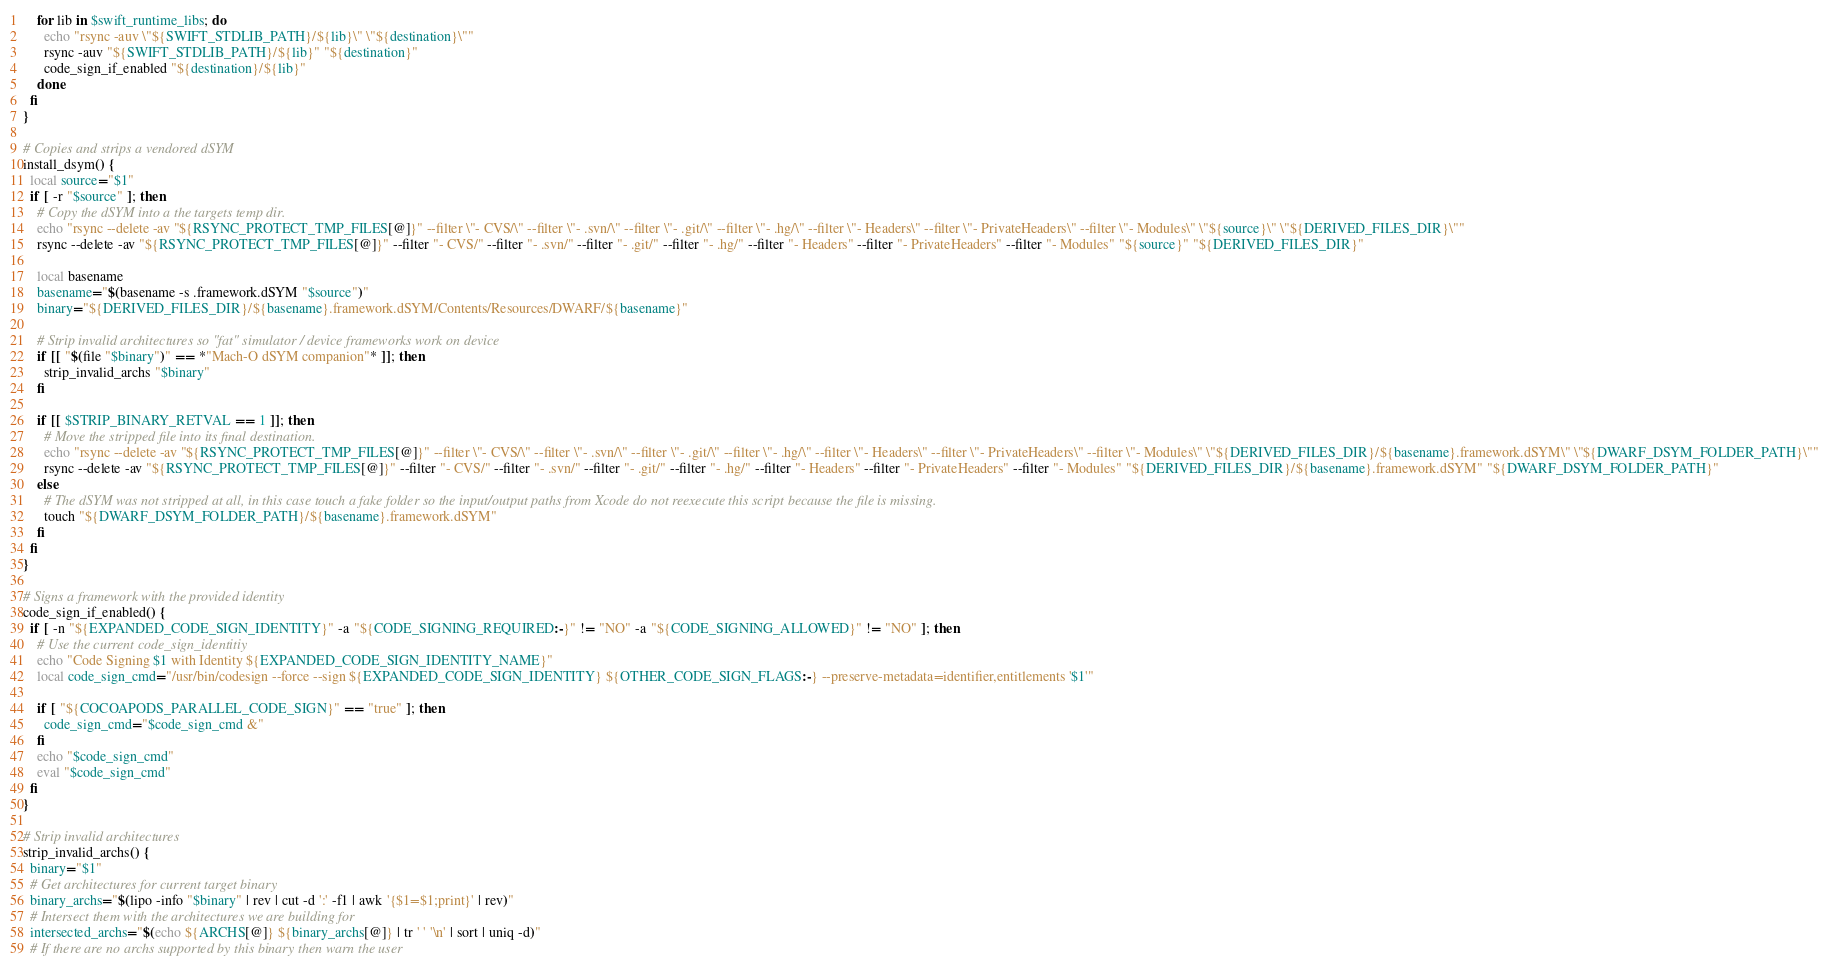<code> <loc_0><loc_0><loc_500><loc_500><_Bash_>    for lib in $swift_runtime_libs; do
      echo "rsync -auv \"${SWIFT_STDLIB_PATH}/${lib}\" \"${destination}\""
      rsync -auv "${SWIFT_STDLIB_PATH}/${lib}" "${destination}"
      code_sign_if_enabled "${destination}/${lib}"
    done
  fi
}

# Copies and strips a vendored dSYM
install_dsym() {
  local source="$1"
  if [ -r "$source" ]; then
    # Copy the dSYM into a the targets temp dir.
    echo "rsync --delete -av "${RSYNC_PROTECT_TMP_FILES[@]}" --filter \"- CVS/\" --filter \"- .svn/\" --filter \"- .git/\" --filter \"- .hg/\" --filter \"- Headers\" --filter \"- PrivateHeaders\" --filter \"- Modules\" \"${source}\" \"${DERIVED_FILES_DIR}\""
    rsync --delete -av "${RSYNC_PROTECT_TMP_FILES[@]}" --filter "- CVS/" --filter "- .svn/" --filter "- .git/" --filter "- .hg/" --filter "- Headers" --filter "- PrivateHeaders" --filter "- Modules" "${source}" "${DERIVED_FILES_DIR}"

    local basename
    basename="$(basename -s .framework.dSYM "$source")"
    binary="${DERIVED_FILES_DIR}/${basename}.framework.dSYM/Contents/Resources/DWARF/${basename}"

    # Strip invalid architectures so "fat" simulator / device frameworks work on device
    if [[ "$(file "$binary")" == *"Mach-O dSYM companion"* ]]; then
      strip_invalid_archs "$binary"
    fi

    if [[ $STRIP_BINARY_RETVAL == 1 ]]; then
      # Move the stripped file into its final destination.
      echo "rsync --delete -av "${RSYNC_PROTECT_TMP_FILES[@]}" --filter \"- CVS/\" --filter \"- .svn/\" --filter \"- .git/\" --filter \"- .hg/\" --filter \"- Headers\" --filter \"- PrivateHeaders\" --filter \"- Modules\" \"${DERIVED_FILES_DIR}/${basename}.framework.dSYM\" \"${DWARF_DSYM_FOLDER_PATH}\""
      rsync --delete -av "${RSYNC_PROTECT_TMP_FILES[@]}" --filter "- CVS/" --filter "- .svn/" --filter "- .git/" --filter "- .hg/" --filter "- Headers" --filter "- PrivateHeaders" --filter "- Modules" "${DERIVED_FILES_DIR}/${basename}.framework.dSYM" "${DWARF_DSYM_FOLDER_PATH}"
    else
      # The dSYM was not stripped at all, in this case touch a fake folder so the input/output paths from Xcode do not reexecute this script because the file is missing.
      touch "${DWARF_DSYM_FOLDER_PATH}/${basename}.framework.dSYM"
    fi
  fi
}

# Signs a framework with the provided identity
code_sign_if_enabled() {
  if [ -n "${EXPANDED_CODE_SIGN_IDENTITY}" -a "${CODE_SIGNING_REQUIRED:-}" != "NO" -a "${CODE_SIGNING_ALLOWED}" != "NO" ]; then
    # Use the current code_sign_identitiy
    echo "Code Signing $1 with Identity ${EXPANDED_CODE_SIGN_IDENTITY_NAME}"
    local code_sign_cmd="/usr/bin/codesign --force --sign ${EXPANDED_CODE_SIGN_IDENTITY} ${OTHER_CODE_SIGN_FLAGS:-} --preserve-metadata=identifier,entitlements '$1'"

    if [ "${COCOAPODS_PARALLEL_CODE_SIGN}" == "true" ]; then
      code_sign_cmd="$code_sign_cmd &"
    fi
    echo "$code_sign_cmd"
    eval "$code_sign_cmd"
  fi
}

# Strip invalid architectures
strip_invalid_archs() {
  binary="$1"
  # Get architectures for current target binary
  binary_archs="$(lipo -info "$binary" | rev | cut -d ':' -f1 | awk '{$1=$1;print}' | rev)"
  # Intersect them with the architectures we are building for
  intersected_archs="$(echo ${ARCHS[@]} ${binary_archs[@]} | tr ' ' '\n' | sort | uniq -d)"
  # If there are no archs supported by this binary then warn the user</code> 